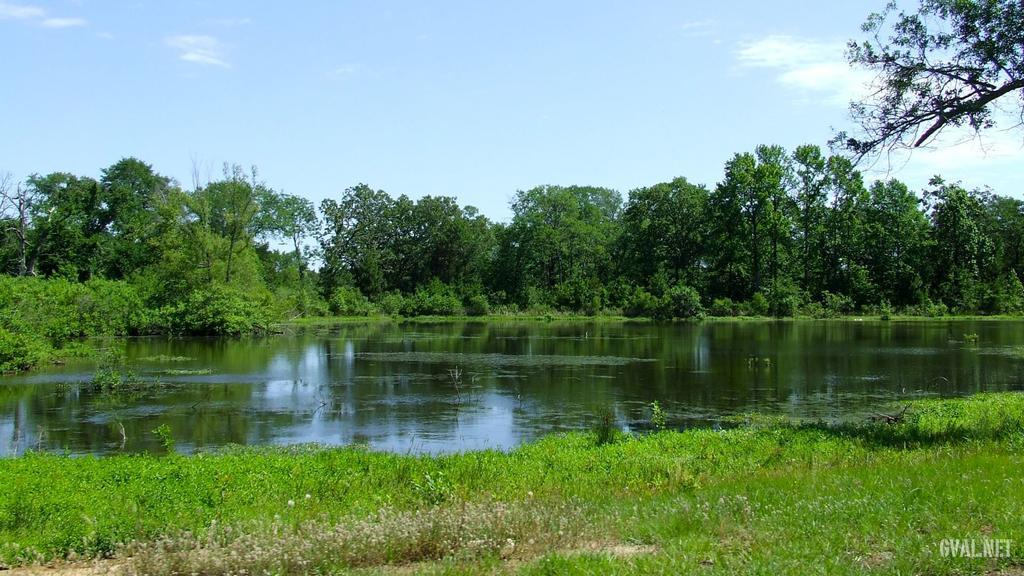What is the main feature in the center of the image? There is water in the center of the image. What type of vegetation is present on the ground in the front of the image? There is grass on the ground in the front of the image. What can be seen in the background of the image? There are trees in the background of the image. How would you describe the sky in the image? The sky is cloudy in the image. What type of nerve can be seen in the image? There is no nerve present in the image; it features water, grass, trees, and a cloudy sky. 